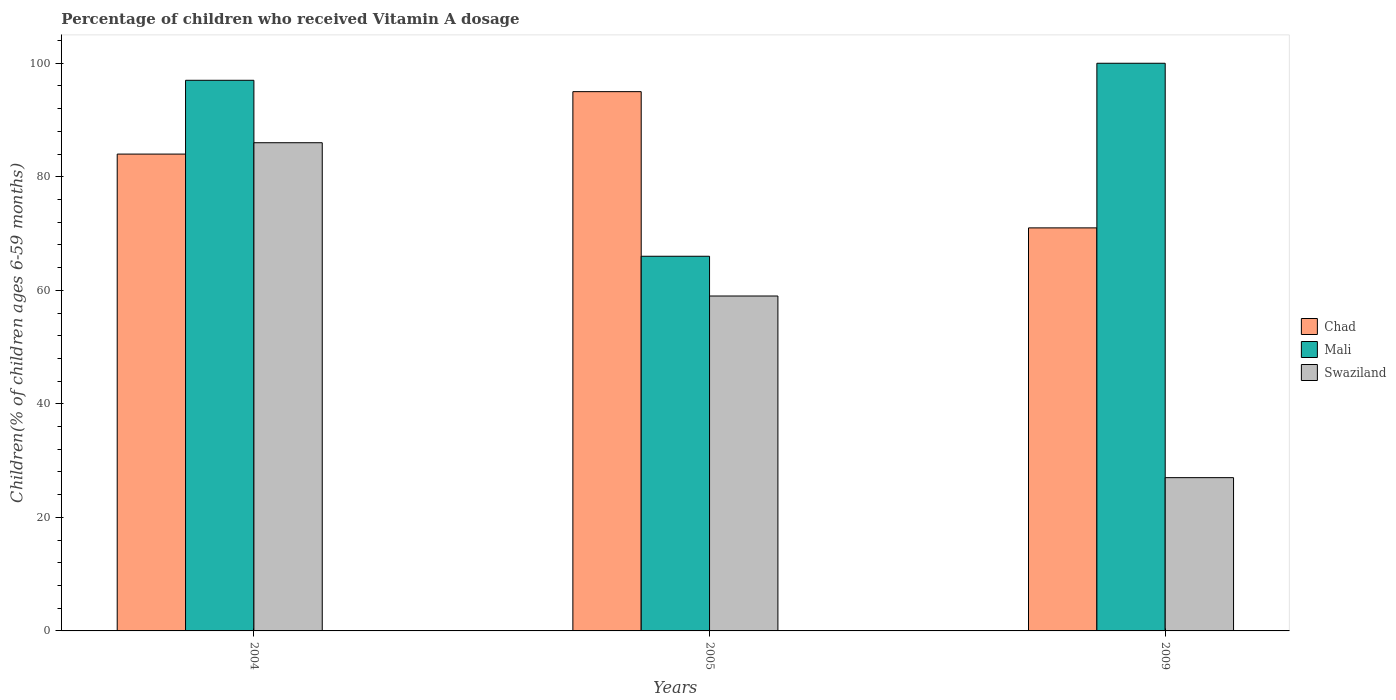How many groups of bars are there?
Provide a short and direct response. 3. What is the label of the 1st group of bars from the left?
Give a very brief answer. 2004. In how many cases, is the number of bars for a given year not equal to the number of legend labels?
Provide a succinct answer. 0. Across all years, what is the maximum percentage of children who received Vitamin A dosage in Mali?
Offer a very short reply. 100. Across all years, what is the minimum percentage of children who received Vitamin A dosage in Chad?
Your response must be concise. 71. What is the total percentage of children who received Vitamin A dosage in Chad in the graph?
Provide a short and direct response. 250. What is the difference between the percentage of children who received Vitamin A dosage in Swaziland in 2009 and the percentage of children who received Vitamin A dosage in Chad in 2004?
Provide a succinct answer. -57. What is the average percentage of children who received Vitamin A dosage in Chad per year?
Make the answer very short. 83.33. What is the ratio of the percentage of children who received Vitamin A dosage in Mali in 2004 to that in 2005?
Make the answer very short. 1.47. Is the difference between the percentage of children who received Vitamin A dosage in Chad in 2004 and 2005 greater than the difference between the percentage of children who received Vitamin A dosage in Mali in 2004 and 2005?
Offer a very short reply. No. What is the difference between the highest and the second highest percentage of children who received Vitamin A dosage in Mali?
Provide a succinct answer. 3. Is the sum of the percentage of children who received Vitamin A dosage in Mali in 2004 and 2009 greater than the maximum percentage of children who received Vitamin A dosage in Swaziland across all years?
Offer a terse response. Yes. What does the 2nd bar from the left in 2009 represents?
Ensure brevity in your answer.  Mali. What does the 1st bar from the right in 2009 represents?
Give a very brief answer. Swaziland. How many bars are there?
Give a very brief answer. 9. Are all the bars in the graph horizontal?
Provide a short and direct response. No. How many years are there in the graph?
Your answer should be very brief. 3. Are the values on the major ticks of Y-axis written in scientific E-notation?
Offer a very short reply. No. Does the graph contain any zero values?
Your answer should be compact. No. Does the graph contain grids?
Provide a succinct answer. No. Where does the legend appear in the graph?
Your answer should be very brief. Center right. What is the title of the graph?
Keep it short and to the point. Percentage of children who received Vitamin A dosage. What is the label or title of the X-axis?
Your response must be concise. Years. What is the label or title of the Y-axis?
Make the answer very short. Children(% of children ages 6-59 months). What is the Children(% of children ages 6-59 months) of Mali in 2004?
Offer a very short reply. 97. What is the Children(% of children ages 6-59 months) of Swaziland in 2004?
Provide a succinct answer. 86. What is the Children(% of children ages 6-59 months) of Chad in 2005?
Your answer should be very brief. 95. What is the Children(% of children ages 6-59 months) in Mali in 2005?
Ensure brevity in your answer.  66. What is the Children(% of children ages 6-59 months) in Mali in 2009?
Make the answer very short. 100. What is the Children(% of children ages 6-59 months) in Swaziland in 2009?
Your response must be concise. 27. Across all years, what is the minimum Children(% of children ages 6-59 months) of Chad?
Offer a terse response. 71. Across all years, what is the minimum Children(% of children ages 6-59 months) of Mali?
Your response must be concise. 66. Across all years, what is the minimum Children(% of children ages 6-59 months) of Swaziland?
Ensure brevity in your answer.  27. What is the total Children(% of children ages 6-59 months) in Chad in the graph?
Your response must be concise. 250. What is the total Children(% of children ages 6-59 months) of Mali in the graph?
Your response must be concise. 263. What is the total Children(% of children ages 6-59 months) in Swaziland in the graph?
Your answer should be compact. 172. What is the difference between the Children(% of children ages 6-59 months) of Chad in 2004 and that in 2005?
Your response must be concise. -11. What is the difference between the Children(% of children ages 6-59 months) in Swaziland in 2004 and that in 2005?
Provide a succinct answer. 27. What is the difference between the Children(% of children ages 6-59 months) of Mali in 2004 and that in 2009?
Ensure brevity in your answer.  -3. What is the difference between the Children(% of children ages 6-59 months) of Swaziland in 2004 and that in 2009?
Your answer should be very brief. 59. What is the difference between the Children(% of children ages 6-59 months) of Chad in 2005 and that in 2009?
Ensure brevity in your answer.  24. What is the difference between the Children(% of children ages 6-59 months) of Mali in 2005 and that in 2009?
Keep it short and to the point. -34. What is the difference between the Children(% of children ages 6-59 months) of Mali in 2004 and the Children(% of children ages 6-59 months) of Swaziland in 2005?
Provide a short and direct response. 38. What is the difference between the Children(% of children ages 6-59 months) in Mali in 2004 and the Children(% of children ages 6-59 months) in Swaziland in 2009?
Offer a very short reply. 70. What is the difference between the Children(% of children ages 6-59 months) of Chad in 2005 and the Children(% of children ages 6-59 months) of Mali in 2009?
Ensure brevity in your answer.  -5. What is the difference between the Children(% of children ages 6-59 months) in Chad in 2005 and the Children(% of children ages 6-59 months) in Swaziland in 2009?
Provide a succinct answer. 68. What is the difference between the Children(% of children ages 6-59 months) of Mali in 2005 and the Children(% of children ages 6-59 months) of Swaziland in 2009?
Make the answer very short. 39. What is the average Children(% of children ages 6-59 months) in Chad per year?
Offer a terse response. 83.33. What is the average Children(% of children ages 6-59 months) in Mali per year?
Provide a short and direct response. 87.67. What is the average Children(% of children ages 6-59 months) in Swaziland per year?
Make the answer very short. 57.33. In the year 2004, what is the difference between the Children(% of children ages 6-59 months) in Chad and Children(% of children ages 6-59 months) in Mali?
Provide a succinct answer. -13. In the year 2005, what is the difference between the Children(% of children ages 6-59 months) in Chad and Children(% of children ages 6-59 months) in Mali?
Provide a succinct answer. 29. In the year 2005, what is the difference between the Children(% of children ages 6-59 months) in Chad and Children(% of children ages 6-59 months) in Swaziland?
Provide a succinct answer. 36. In the year 2009, what is the difference between the Children(% of children ages 6-59 months) of Mali and Children(% of children ages 6-59 months) of Swaziland?
Make the answer very short. 73. What is the ratio of the Children(% of children ages 6-59 months) of Chad in 2004 to that in 2005?
Give a very brief answer. 0.88. What is the ratio of the Children(% of children ages 6-59 months) of Mali in 2004 to that in 2005?
Give a very brief answer. 1.47. What is the ratio of the Children(% of children ages 6-59 months) of Swaziland in 2004 to that in 2005?
Give a very brief answer. 1.46. What is the ratio of the Children(% of children ages 6-59 months) of Chad in 2004 to that in 2009?
Your response must be concise. 1.18. What is the ratio of the Children(% of children ages 6-59 months) in Swaziland in 2004 to that in 2009?
Make the answer very short. 3.19. What is the ratio of the Children(% of children ages 6-59 months) in Chad in 2005 to that in 2009?
Your answer should be very brief. 1.34. What is the ratio of the Children(% of children ages 6-59 months) of Mali in 2005 to that in 2009?
Your response must be concise. 0.66. What is the ratio of the Children(% of children ages 6-59 months) in Swaziland in 2005 to that in 2009?
Offer a terse response. 2.19. What is the difference between the highest and the second highest Children(% of children ages 6-59 months) of Chad?
Offer a very short reply. 11. What is the difference between the highest and the second highest Children(% of children ages 6-59 months) in Mali?
Ensure brevity in your answer.  3. What is the difference between the highest and the lowest Children(% of children ages 6-59 months) in Chad?
Offer a very short reply. 24. 